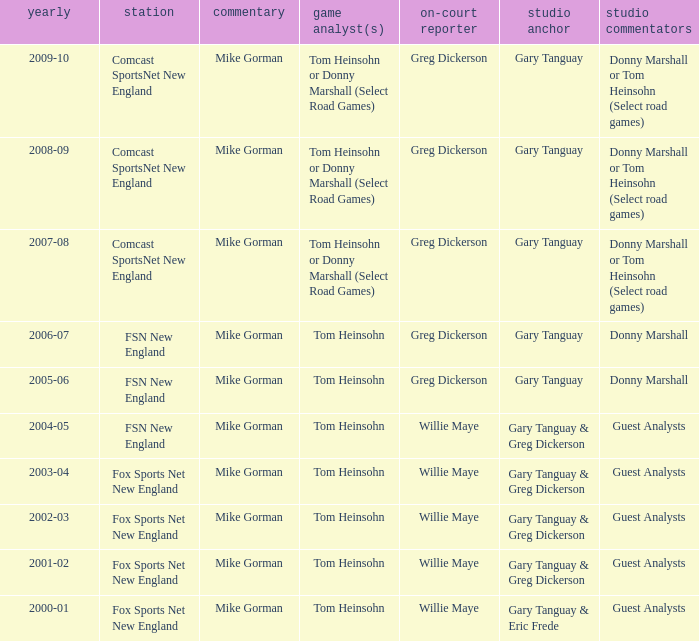WHich Studio analysts has a Studio host of gary tanguay in 2009-10? Donny Marshall or Tom Heinsohn (Select road games). 